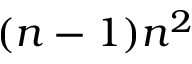<formula> <loc_0><loc_0><loc_500><loc_500>( n - 1 ) n ^ { 2 }</formula> 